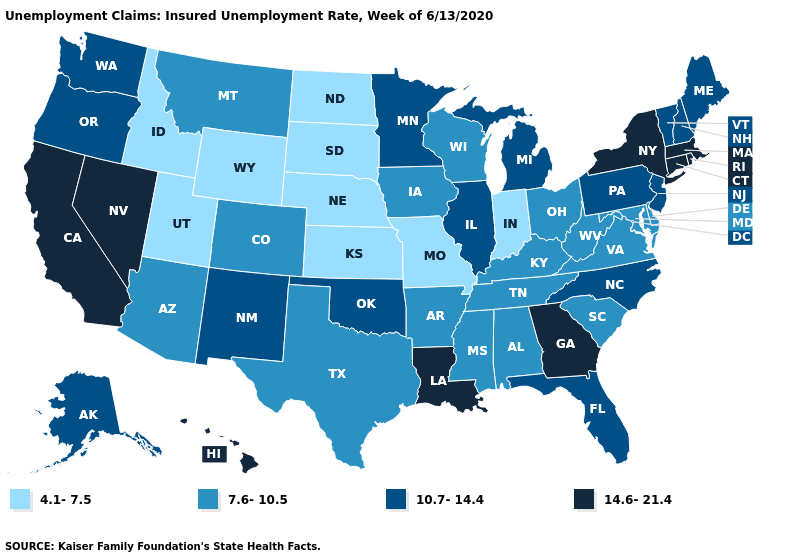Name the states that have a value in the range 4.1-7.5?
Be succinct. Idaho, Indiana, Kansas, Missouri, Nebraska, North Dakota, South Dakota, Utah, Wyoming. What is the value of Tennessee?
Write a very short answer. 7.6-10.5. Is the legend a continuous bar?
Quick response, please. No. Does Pennsylvania have the lowest value in the Northeast?
Concise answer only. Yes. What is the value of New Mexico?
Keep it brief. 10.7-14.4. What is the value of Indiana?
Be succinct. 4.1-7.5. Is the legend a continuous bar?
Short answer required. No. Is the legend a continuous bar?
Answer briefly. No. Does the map have missing data?
Quick response, please. No. What is the lowest value in the South?
Answer briefly. 7.6-10.5. What is the value of Idaho?
Short answer required. 4.1-7.5. What is the value of Washington?
Answer briefly. 10.7-14.4. Does the map have missing data?
Answer briefly. No. Name the states that have a value in the range 7.6-10.5?
Concise answer only. Alabama, Arizona, Arkansas, Colorado, Delaware, Iowa, Kentucky, Maryland, Mississippi, Montana, Ohio, South Carolina, Tennessee, Texas, Virginia, West Virginia, Wisconsin. What is the value of South Dakota?
Concise answer only. 4.1-7.5. 